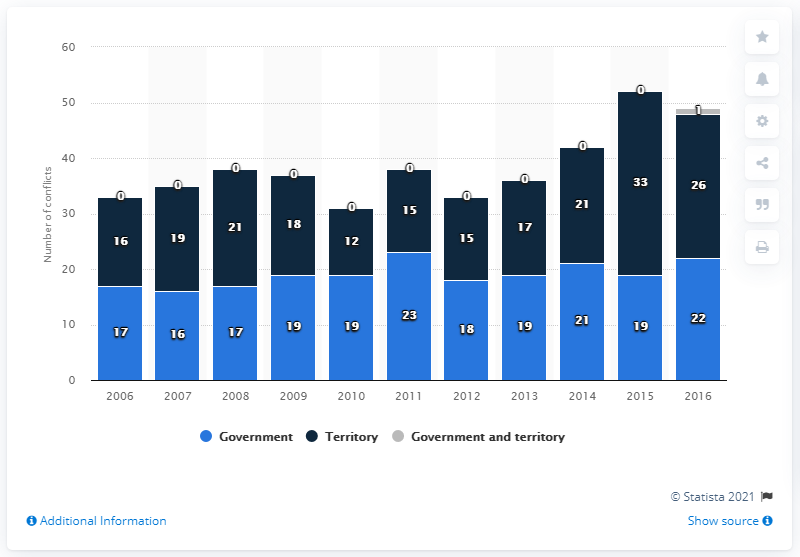Give some essential details in this illustration. In 2016, there were 26 conflicts that were primarily motivated by territorial disputes. 